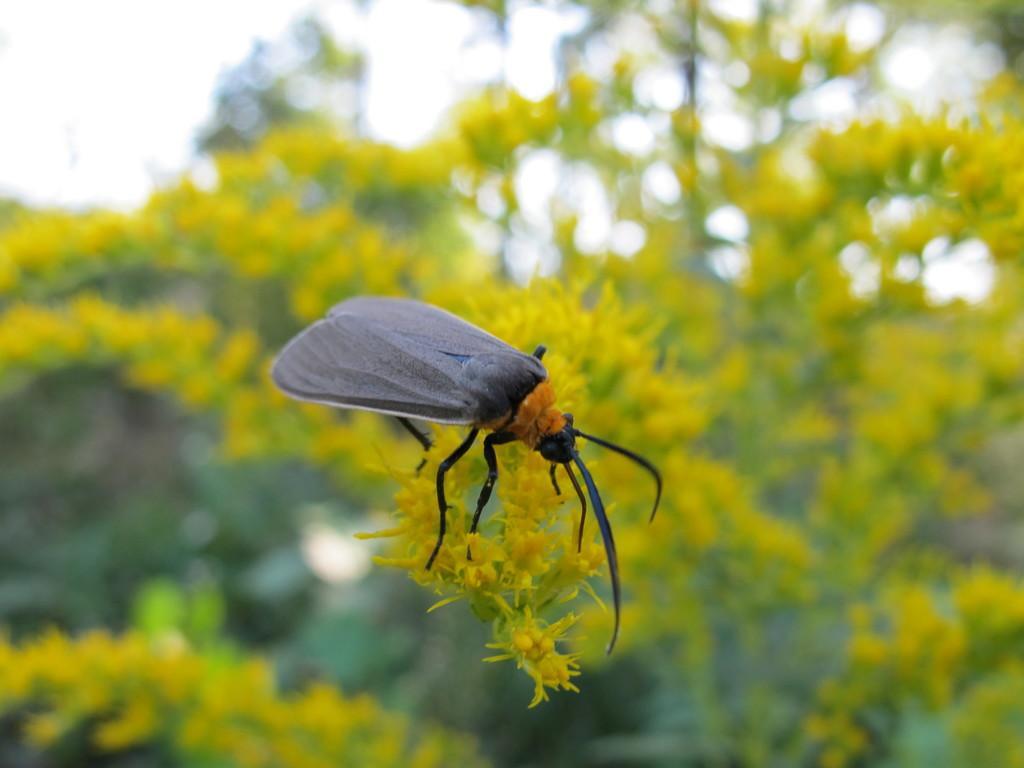In one or two sentences, can you explain what this image depicts? In this picture we can see an insect on the flowers, in the background we can see few trees. 